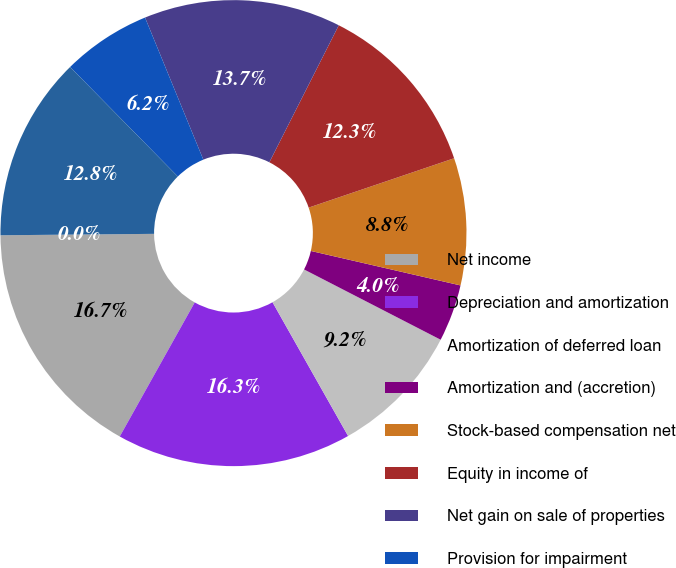<chart> <loc_0><loc_0><loc_500><loc_500><pie_chart><fcel>Net income<fcel>Depreciation and amortization<fcel>Amortization of deferred loan<fcel>Amortization and (accretion)<fcel>Stock-based compensation net<fcel>Equity in income of<fcel>Net gain on sale of properties<fcel>Provision for impairment<fcel>Distribution of earnings from<fcel>(Gain) loss on derivative<nl><fcel>16.74%<fcel>16.3%<fcel>9.25%<fcel>3.96%<fcel>8.81%<fcel>12.33%<fcel>13.66%<fcel>6.17%<fcel>12.78%<fcel>0.0%<nl></chart> 